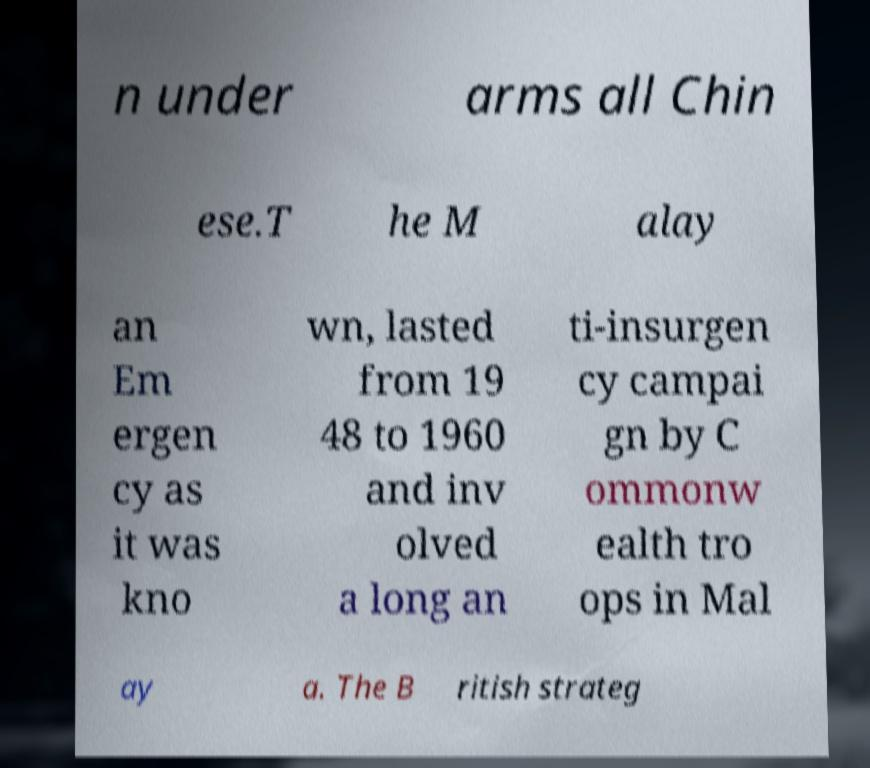Please read and relay the text visible in this image. What does it say? n under arms all Chin ese.T he M alay an Em ergen cy as it was kno wn, lasted from 19 48 to 1960 and inv olved a long an ti-insurgen cy campai gn by C ommonw ealth tro ops in Mal ay a. The B ritish strateg 